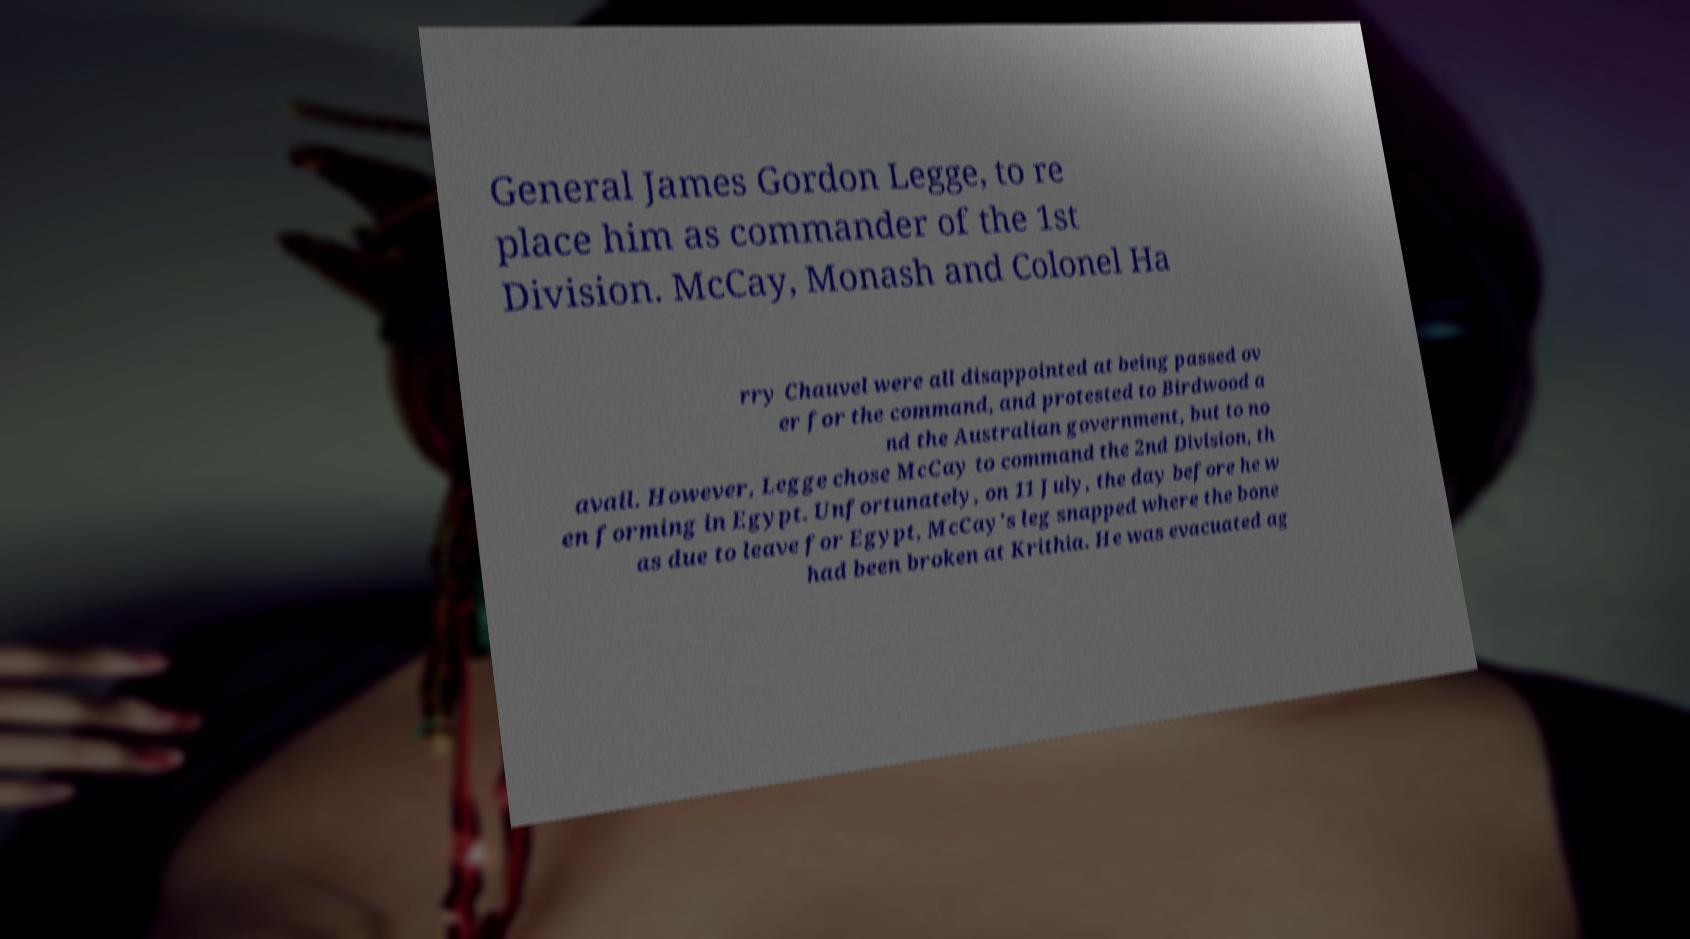Please identify and transcribe the text found in this image. General James Gordon Legge, to re place him as commander of the 1st Division. McCay, Monash and Colonel Ha rry Chauvel were all disappointed at being passed ov er for the command, and protested to Birdwood a nd the Australian government, but to no avail. However, Legge chose McCay to command the 2nd Division, th en forming in Egypt. Unfortunately, on 11 July, the day before he w as due to leave for Egypt, McCay's leg snapped where the bone had been broken at Krithia. He was evacuated ag 